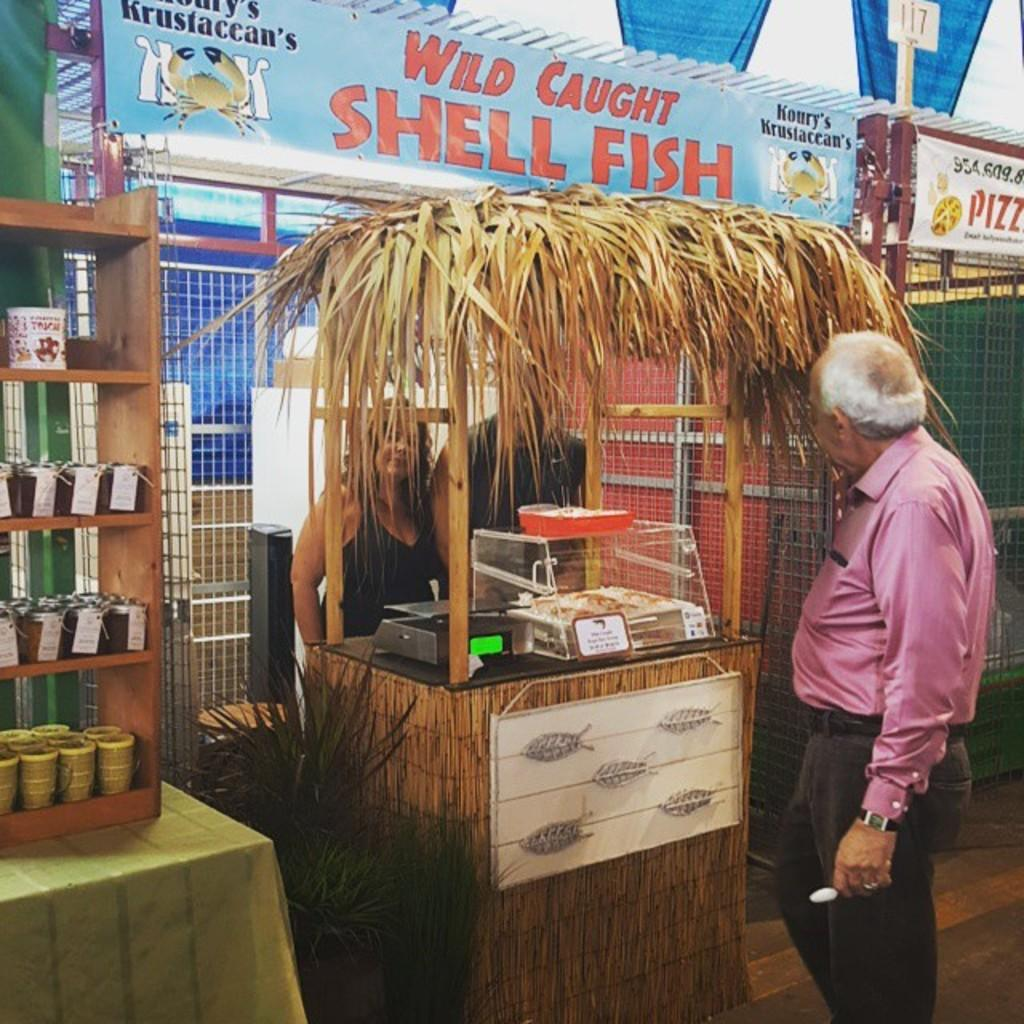<image>
Write a terse but informative summary of the picture. A man standing at a booth with a sign about shellfish above it. 